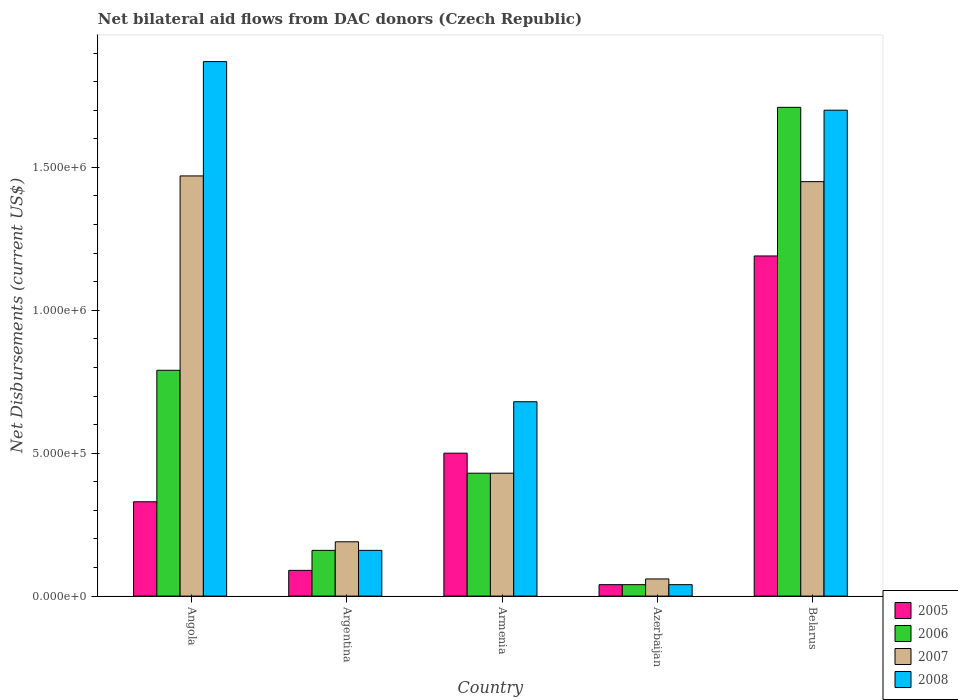How many different coloured bars are there?
Your response must be concise. 4. Are the number of bars per tick equal to the number of legend labels?
Provide a short and direct response. Yes. How many bars are there on the 5th tick from the right?
Your answer should be very brief. 4. What is the label of the 4th group of bars from the left?
Provide a short and direct response. Azerbaijan. What is the net bilateral aid flows in 2008 in Azerbaijan?
Give a very brief answer. 4.00e+04. Across all countries, what is the maximum net bilateral aid flows in 2006?
Give a very brief answer. 1.71e+06. Across all countries, what is the minimum net bilateral aid flows in 2005?
Keep it short and to the point. 4.00e+04. In which country was the net bilateral aid flows in 2005 maximum?
Ensure brevity in your answer.  Belarus. In which country was the net bilateral aid flows in 2005 minimum?
Ensure brevity in your answer.  Azerbaijan. What is the total net bilateral aid flows in 2008 in the graph?
Provide a succinct answer. 4.45e+06. What is the difference between the net bilateral aid flows in 2006 in Armenia and that in Azerbaijan?
Offer a terse response. 3.90e+05. What is the difference between the net bilateral aid flows in 2008 in Angola and the net bilateral aid flows in 2006 in Azerbaijan?
Your answer should be compact. 1.83e+06. What is the average net bilateral aid flows in 2005 per country?
Offer a terse response. 4.30e+05. What is the difference between the net bilateral aid flows of/in 2006 and net bilateral aid flows of/in 2007 in Angola?
Ensure brevity in your answer.  -6.80e+05. What is the ratio of the net bilateral aid flows in 2005 in Angola to that in Azerbaijan?
Provide a succinct answer. 8.25. Is the net bilateral aid flows in 2008 in Armenia less than that in Belarus?
Provide a succinct answer. Yes. What is the difference between the highest and the lowest net bilateral aid flows in 2008?
Your response must be concise. 1.83e+06. In how many countries, is the net bilateral aid flows in 2007 greater than the average net bilateral aid flows in 2007 taken over all countries?
Give a very brief answer. 2. Is it the case that in every country, the sum of the net bilateral aid flows in 2006 and net bilateral aid flows in 2008 is greater than the sum of net bilateral aid flows in 2005 and net bilateral aid flows in 2007?
Provide a short and direct response. No. What does the 2nd bar from the left in Argentina represents?
Keep it short and to the point. 2006. Is it the case that in every country, the sum of the net bilateral aid flows in 2008 and net bilateral aid flows in 2006 is greater than the net bilateral aid flows in 2007?
Make the answer very short. Yes. How many bars are there?
Offer a very short reply. 20. How many countries are there in the graph?
Provide a succinct answer. 5. What is the difference between two consecutive major ticks on the Y-axis?
Offer a terse response. 5.00e+05. Does the graph contain grids?
Offer a terse response. No. How are the legend labels stacked?
Provide a succinct answer. Vertical. What is the title of the graph?
Your answer should be compact. Net bilateral aid flows from DAC donors (Czech Republic). Does "1976" appear as one of the legend labels in the graph?
Your response must be concise. No. What is the label or title of the Y-axis?
Your answer should be compact. Net Disbursements (current US$). What is the Net Disbursements (current US$) in 2006 in Angola?
Offer a very short reply. 7.90e+05. What is the Net Disbursements (current US$) of 2007 in Angola?
Your response must be concise. 1.47e+06. What is the Net Disbursements (current US$) in 2008 in Angola?
Provide a succinct answer. 1.87e+06. What is the Net Disbursements (current US$) of 2005 in Argentina?
Ensure brevity in your answer.  9.00e+04. What is the Net Disbursements (current US$) of 2007 in Argentina?
Your response must be concise. 1.90e+05. What is the Net Disbursements (current US$) in 2006 in Armenia?
Ensure brevity in your answer.  4.30e+05. What is the Net Disbursements (current US$) of 2008 in Armenia?
Your answer should be very brief. 6.80e+05. What is the Net Disbursements (current US$) in 2005 in Azerbaijan?
Make the answer very short. 4.00e+04. What is the Net Disbursements (current US$) of 2006 in Azerbaijan?
Keep it short and to the point. 4.00e+04. What is the Net Disbursements (current US$) of 2005 in Belarus?
Your answer should be very brief. 1.19e+06. What is the Net Disbursements (current US$) in 2006 in Belarus?
Offer a terse response. 1.71e+06. What is the Net Disbursements (current US$) in 2007 in Belarus?
Offer a terse response. 1.45e+06. What is the Net Disbursements (current US$) in 2008 in Belarus?
Your answer should be compact. 1.70e+06. Across all countries, what is the maximum Net Disbursements (current US$) of 2005?
Offer a very short reply. 1.19e+06. Across all countries, what is the maximum Net Disbursements (current US$) in 2006?
Your answer should be compact. 1.71e+06. Across all countries, what is the maximum Net Disbursements (current US$) of 2007?
Offer a very short reply. 1.47e+06. Across all countries, what is the maximum Net Disbursements (current US$) in 2008?
Provide a short and direct response. 1.87e+06. Across all countries, what is the minimum Net Disbursements (current US$) in 2005?
Your response must be concise. 4.00e+04. Across all countries, what is the minimum Net Disbursements (current US$) of 2008?
Your response must be concise. 4.00e+04. What is the total Net Disbursements (current US$) of 2005 in the graph?
Offer a terse response. 2.15e+06. What is the total Net Disbursements (current US$) of 2006 in the graph?
Offer a very short reply. 3.13e+06. What is the total Net Disbursements (current US$) in 2007 in the graph?
Offer a terse response. 3.60e+06. What is the total Net Disbursements (current US$) in 2008 in the graph?
Offer a very short reply. 4.45e+06. What is the difference between the Net Disbursements (current US$) in 2005 in Angola and that in Argentina?
Provide a short and direct response. 2.40e+05. What is the difference between the Net Disbursements (current US$) in 2006 in Angola and that in Argentina?
Provide a short and direct response. 6.30e+05. What is the difference between the Net Disbursements (current US$) in 2007 in Angola and that in Argentina?
Make the answer very short. 1.28e+06. What is the difference between the Net Disbursements (current US$) in 2008 in Angola and that in Argentina?
Keep it short and to the point. 1.71e+06. What is the difference between the Net Disbursements (current US$) in 2005 in Angola and that in Armenia?
Make the answer very short. -1.70e+05. What is the difference between the Net Disbursements (current US$) in 2007 in Angola and that in Armenia?
Offer a very short reply. 1.04e+06. What is the difference between the Net Disbursements (current US$) in 2008 in Angola and that in Armenia?
Ensure brevity in your answer.  1.19e+06. What is the difference between the Net Disbursements (current US$) of 2005 in Angola and that in Azerbaijan?
Ensure brevity in your answer.  2.90e+05. What is the difference between the Net Disbursements (current US$) of 2006 in Angola and that in Azerbaijan?
Make the answer very short. 7.50e+05. What is the difference between the Net Disbursements (current US$) in 2007 in Angola and that in Azerbaijan?
Ensure brevity in your answer.  1.41e+06. What is the difference between the Net Disbursements (current US$) of 2008 in Angola and that in Azerbaijan?
Provide a short and direct response. 1.83e+06. What is the difference between the Net Disbursements (current US$) in 2005 in Angola and that in Belarus?
Keep it short and to the point. -8.60e+05. What is the difference between the Net Disbursements (current US$) of 2006 in Angola and that in Belarus?
Your response must be concise. -9.20e+05. What is the difference between the Net Disbursements (current US$) in 2007 in Angola and that in Belarus?
Give a very brief answer. 2.00e+04. What is the difference between the Net Disbursements (current US$) in 2008 in Angola and that in Belarus?
Provide a short and direct response. 1.70e+05. What is the difference between the Net Disbursements (current US$) of 2005 in Argentina and that in Armenia?
Make the answer very short. -4.10e+05. What is the difference between the Net Disbursements (current US$) of 2006 in Argentina and that in Armenia?
Offer a terse response. -2.70e+05. What is the difference between the Net Disbursements (current US$) in 2007 in Argentina and that in Armenia?
Your response must be concise. -2.40e+05. What is the difference between the Net Disbursements (current US$) in 2008 in Argentina and that in Armenia?
Provide a short and direct response. -5.20e+05. What is the difference between the Net Disbursements (current US$) of 2005 in Argentina and that in Belarus?
Make the answer very short. -1.10e+06. What is the difference between the Net Disbursements (current US$) of 2006 in Argentina and that in Belarus?
Offer a very short reply. -1.55e+06. What is the difference between the Net Disbursements (current US$) in 2007 in Argentina and that in Belarus?
Your response must be concise. -1.26e+06. What is the difference between the Net Disbursements (current US$) of 2008 in Argentina and that in Belarus?
Give a very brief answer. -1.54e+06. What is the difference between the Net Disbursements (current US$) in 2007 in Armenia and that in Azerbaijan?
Your response must be concise. 3.70e+05. What is the difference between the Net Disbursements (current US$) in 2008 in Armenia and that in Azerbaijan?
Offer a very short reply. 6.40e+05. What is the difference between the Net Disbursements (current US$) in 2005 in Armenia and that in Belarus?
Give a very brief answer. -6.90e+05. What is the difference between the Net Disbursements (current US$) in 2006 in Armenia and that in Belarus?
Make the answer very short. -1.28e+06. What is the difference between the Net Disbursements (current US$) of 2007 in Armenia and that in Belarus?
Make the answer very short. -1.02e+06. What is the difference between the Net Disbursements (current US$) in 2008 in Armenia and that in Belarus?
Your answer should be compact. -1.02e+06. What is the difference between the Net Disbursements (current US$) of 2005 in Azerbaijan and that in Belarus?
Provide a succinct answer. -1.15e+06. What is the difference between the Net Disbursements (current US$) in 2006 in Azerbaijan and that in Belarus?
Give a very brief answer. -1.67e+06. What is the difference between the Net Disbursements (current US$) in 2007 in Azerbaijan and that in Belarus?
Make the answer very short. -1.39e+06. What is the difference between the Net Disbursements (current US$) of 2008 in Azerbaijan and that in Belarus?
Offer a very short reply. -1.66e+06. What is the difference between the Net Disbursements (current US$) in 2005 in Angola and the Net Disbursements (current US$) in 2007 in Argentina?
Provide a short and direct response. 1.40e+05. What is the difference between the Net Disbursements (current US$) of 2005 in Angola and the Net Disbursements (current US$) of 2008 in Argentina?
Provide a short and direct response. 1.70e+05. What is the difference between the Net Disbursements (current US$) of 2006 in Angola and the Net Disbursements (current US$) of 2007 in Argentina?
Your answer should be compact. 6.00e+05. What is the difference between the Net Disbursements (current US$) of 2006 in Angola and the Net Disbursements (current US$) of 2008 in Argentina?
Provide a succinct answer. 6.30e+05. What is the difference between the Net Disbursements (current US$) in 2007 in Angola and the Net Disbursements (current US$) in 2008 in Argentina?
Keep it short and to the point. 1.31e+06. What is the difference between the Net Disbursements (current US$) in 2005 in Angola and the Net Disbursements (current US$) in 2006 in Armenia?
Your answer should be very brief. -1.00e+05. What is the difference between the Net Disbursements (current US$) in 2005 in Angola and the Net Disbursements (current US$) in 2007 in Armenia?
Keep it short and to the point. -1.00e+05. What is the difference between the Net Disbursements (current US$) of 2005 in Angola and the Net Disbursements (current US$) of 2008 in Armenia?
Your answer should be very brief. -3.50e+05. What is the difference between the Net Disbursements (current US$) in 2006 in Angola and the Net Disbursements (current US$) in 2007 in Armenia?
Your response must be concise. 3.60e+05. What is the difference between the Net Disbursements (current US$) in 2006 in Angola and the Net Disbursements (current US$) in 2008 in Armenia?
Ensure brevity in your answer.  1.10e+05. What is the difference between the Net Disbursements (current US$) of 2007 in Angola and the Net Disbursements (current US$) of 2008 in Armenia?
Provide a short and direct response. 7.90e+05. What is the difference between the Net Disbursements (current US$) in 2006 in Angola and the Net Disbursements (current US$) in 2007 in Azerbaijan?
Provide a short and direct response. 7.30e+05. What is the difference between the Net Disbursements (current US$) of 2006 in Angola and the Net Disbursements (current US$) of 2008 in Azerbaijan?
Offer a very short reply. 7.50e+05. What is the difference between the Net Disbursements (current US$) in 2007 in Angola and the Net Disbursements (current US$) in 2008 in Azerbaijan?
Give a very brief answer. 1.43e+06. What is the difference between the Net Disbursements (current US$) of 2005 in Angola and the Net Disbursements (current US$) of 2006 in Belarus?
Offer a terse response. -1.38e+06. What is the difference between the Net Disbursements (current US$) of 2005 in Angola and the Net Disbursements (current US$) of 2007 in Belarus?
Provide a short and direct response. -1.12e+06. What is the difference between the Net Disbursements (current US$) in 2005 in Angola and the Net Disbursements (current US$) in 2008 in Belarus?
Provide a succinct answer. -1.37e+06. What is the difference between the Net Disbursements (current US$) of 2006 in Angola and the Net Disbursements (current US$) of 2007 in Belarus?
Your response must be concise. -6.60e+05. What is the difference between the Net Disbursements (current US$) of 2006 in Angola and the Net Disbursements (current US$) of 2008 in Belarus?
Make the answer very short. -9.10e+05. What is the difference between the Net Disbursements (current US$) of 2005 in Argentina and the Net Disbursements (current US$) of 2006 in Armenia?
Ensure brevity in your answer.  -3.40e+05. What is the difference between the Net Disbursements (current US$) in 2005 in Argentina and the Net Disbursements (current US$) in 2008 in Armenia?
Keep it short and to the point. -5.90e+05. What is the difference between the Net Disbursements (current US$) in 2006 in Argentina and the Net Disbursements (current US$) in 2007 in Armenia?
Your answer should be compact. -2.70e+05. What is the difference between the Net Disbursements (current US$) of 2006 in Argentina and the Net Disbursements (current US$) of 2008 in Armenia?
Offer a very short reply. -5.20e+05. What is the difference between the Net Disbursements (current US$) in 2007 in Argentina and the Net Disbursements (current US$) in 2008 in Armenia?
Your answer should be very brief. -4.90e+05. What is the difference between the Net Disbursements (current US$) of 2005 in Argentina and the Net Disbursements (current US$) of 2007 in Azerbaijan?
Make the answer very short. 3.00e+04. What is the difference between the Net Disbursements (current US$) of 2006 in Argentina and the Net Disbursements (current US$) of 2008 in Azerbaijan?
Give a very brief answer. 1.20e+05. What is the difference between the Net Disbursements (current US$) in 2007 in Argentina and the Net Disbursements (current US$) in 2008 in Azerbaijan?
Your answer should be compact. 1.50e+05. What is the difference between the Net Disbursements (current US$) of 2005 in Argentina and the Net Disbursements (current US$) of 2006 in Belarus?
Make the answer very short. -1.62e+06. What is the difference between the Net Disbursements (current US$) of 2005 in Argentina and the Net Disbursements (current US$) of 2007 in Belarus?
Make the answer very short. -1.36e+06. What is the difference between the Net Disbursements (current US$) in 2005 in Argentina and the Net Disbursements (current US$) in 2008 in Belarus?
Make the answer very short. -1.61e+06. What is the difference between the Net Disbursements (current US$) in 2006 in Argentina and the Net Disbursements (current US$) in 2007 in Belarus?
Your answer should be very brief. -1.29e+06. What is the difference between the Net Disbursements (current US$) in 2006 in Argentina and the Net Disbursements (current US$) in 2008 in Belarus?
Your answer should be very brief. -1.54e+06. What is the difference between the Net Disbursements (current US$) in 2007 in Argentina and the Net Disbursements (current US$) in 2008 in Belarus?
Make the answer very short. -1.51e+06. What is the difference between the Net Disbursements (current US$) of 2006 in Armenia and the Net Disbursements (current US$) of 2007 in Azerbaijan?
Your response must be concise. 3.70e+05. What is the difference between the Net Disbursements (current US$) of 2007 in Armenia and the Net Disbursements (current US$) of 2008 in Azerbaijan?
Provide a short and direct response. 3.90e+05. What is the difference between the Net Disbursements (current US$) of 2005 in Armenia and the Net Disbursements (current US$) of 2006 in Belarus?
Offer a terse response. -1.21e+06. What is the difference between the Net Disbursements (current US$) in 2005 in Armenia and the Net Disbursements (current US$) in 2007 in Belarus?
Provide a succinct answer. -9.50e+05. What is the difference between the Net Disbursements (current US$) in 2005 in Armenia and the Net Disbursements (current US$) in 2008 in Belarus?
Your response must be concise. -1.20e+06. What is the difference between the Net Disbursements (current US$) in 2006 in Armenia and the Net Disbursements (current US$) in 2007 in Belarus?
Your answer should be compact. -1.02e+06. What is the difference between the Net Disbursements (current US$) of 2006 in Armenia and the Net Disbursements (current US$) of 2008 in Belarus?
Provide a short and direct response. -1.27e+06. What is the difference between the Net Disbursements (current US$) in 2007 in Armenia and the Net Disbursements (current US$) in 2008 in Belarus?
Give a very brief answer. -1.27e+06. What is the difference between the Net Disbursements (current US$) of 2005 in Azerbaijan and the Net Disbursements (current US$) of 2006 in Belarus?
Your answer should be very brief. -1.67e+06. What is the difference between the Net Disbursements (current US$) in 2005 in Azerbaijan and the Net Disbursements (current US$) in 2007 in Belarus?
Give a very brief answer. -1.41e+06. What is the difference between the Net Disbursements (current US$) in 2005 in Azerbaijan and the Net Disbursements (current US$) in 2008 in Belarus?
Your response must be concise. -1.66e+06. What is the difference between the Net Disbursements (current US$) in 2006 in Azerbaijan and the Net Disbursements (current US$) in 2007 in Belarus?
Make the answer very short. -1.41e+06. What is the difference between the Net Disbursements (current US$) of 2006 in Azerbaijan and the Net Disbursements (current US$) of 2008 in Belarus?
Offer a terse response. -1.66e+06. What is the difference between the Net Disbursements (current US$) of 2007 in Azerbaijan and the Net Disbursements (current US$) of 2008 in Belarus?
Give a very brief answer. -1.64e+06. What is the average Net Disbursements (current US$) in 2006 per country?
Keep it short and to the point. 6.26e+05. What is the average Net Disbursements (current US$) of 2007 per country?
Give a very brief answer. 7.20e+05. What is the average Net Disbursements (current US$) in 2008 per country?
Give a very brief answer. 8.90e+05. What is the difference between the Net Disbursements (current US$) in 2005 and Net Disbursements (current US$) in 2006 in Angola?
Offer a very short reply. -4.60e+05. What is the difference between the Net Disbursements (current US$) of 2005 and Net Disbursements (current US$) of 2007 in Angola?
Offer a terse response. -1.14e+06. What is the difference between the Net Disbursements (current US$) in 2005 and Net Disbursements (current US$) in 2008 in Angola?
Make the answer very short. -1.54e+06. What is the difference between the Net Disbursements (current US$) of 2006 and Net Disbursements (current US$) of 2007 in Angola?
Offer a terse response. -6.80e+05. What is the difference between the Net Disbursements (current US$) in 2006 and Net Disbursements (current US$) in 2008 in Angola?
Your response must be concise. -1.08e+06. What is the difference between the Net Disbursements (current US$) in 2007 and Net Disbursements (current US$) in 2008 in Angola?
Provide a succinct answer. -4.00e+05. What is the difference between the Net Disbursements (current US$) in 2005 and Net Disbursements (current US$) in 2007 in Argentina?
Your response must be concise. -1.00e+05. What is the difference between the Net Disbursements (current US$) in 2006 and Net Disbursements (current US$) in 2007 in Argentina?
Ensure brevity in your answer.  -3.00e+04. What is the difference between the Net Disbursements (current US$) in 2006 and Net Disbursements (current US$) in 2008 in Argentina?
Make the answer very short. 0. What is the difference between the Net Disbursements (current US$) of 2007 and Net Disbursements (current US$) of 2008 in Argentina?
Make the answer very short. 3.00e+04. What is the difference between the Net Disbursements (current US$) of 2005 and Net Disbursements (current US$) of 2006 in Armenia?
Provide a short and direct response. 7.00e+04. What is the difference between the Net Disbursements (current US$) of 2005 and Net Disbursements (current US$) of 2008 in Armenia?
Provide a succinct answer. -1.80e+05. What is the difference between the Net Disbursements (current US$) of 2006 and Net Disbursements (current US$) of 2007 in Armenia?
Offer a terse response. 0. What is the difference between the Net Disbursements (current US$) of 2007 and Net Disbursements (current US$) of 2008 in Armenia?
Ensure brevity in your answer.  -2.50e+05. What is the difference between the Net Disbursements (current US$) in 2005 and Net Disbursements (current US$) in 2007 in Azerbaijan?
Make the answer very short. -2.00e+04. What is the difference between the Net Disbursements (current US$) of 2006 and Net Disbursements (current US$) of 2007 in Azerbaijan?
Your answer should be compact. -2.00e+04. What is the difference between the Net Disbursements (current US$) of 2006 and Net Disbursements (current US$) of 2008 in Azerbaijan?
Keep it short and to the point. 0. What is the difference between the Net Disbursements (current US$) of 2007 and Net Disbursements (current US$) of 2008 in Azerbaijan?
Offer a terse response. 2.00e+04. What is the difference between the Net Disbursements (current US$) of 2005 and Net Disbursements (current US$) of 2006 in Belarus?
Offer a very short reply. -5.20e+05. What is the difference between the Net Disbursements (current US$) in 2005 and Net Disbursements (current US$) in 2007 in Belarus?
Your answer should be very brief. -2.60e+05. What is the difference between the Net Disbursements (current US$) of 2005 and Net Disbursements (current US$) of 2008 in Belarus?
Make the answer very short. -5.10e+05. What is the difference between the Net Disbursements (current US$) in 2006 and Net Disbursements (current US$) in 2008 in Belarus?
Your answer should be very brief. 10000. What is the ratio of the Net Disbursements (current US$) in 2005 in Angola to that in Argentina?
Give a very brief answer. 3.67. What is the ratio of the Net Disbursements (current US$) in 2006 in Angola to that in Argentina?
Your answer should be very brief. 4.94. What is the ratio of the Net Disbursements (current US$) in 2007 in Angola to that in Argentina?
Offer a terse response. 7.74. What is the ratio of the Net Disbursements (current US$) in 2008 in Angola to that in Argentina?
Your response must be concise. 11.69. What is the ratio of the Net Disbursements (current US$) of 2005 in Angola to that in Armenia?
Keep it short and to the point. 0.66. What is the ratio of the Net Disbursements (current US$) in 2006 in Angola to that in Armenia?
Provide a short and direct response. 1.84. What is the ratio of the Net Disbursements (current US$) of 2007 in Angola to that in Armenia?
Your response must be concise. 3.42. What is the ratio of the Net Disbursements (current US$) in 2008 in Angola to that in Armenia?
Offer a very short reply. 2.75. What is the ratio of the Net Disbursements (current US$) in 2005 in Angola to that in Azerbaijan?
Give a very brief answer. 8.25. What is the ratio of the Net Disbursements (current US$) in 2006 in Angola to that in Azerbaijan?
Your response must be concise. 19.75. What is the ratio of the Net Disbursements (current US$) in 2007 in Angola to that in Azerbaijan?
Make the answer very short. 24.5. What is the ratio of the Net Disbursements (current US$) of 2008 in Angola to that in Azerbaijan?
Offer a very short reply. 46.75. What is the ratio of the Net Disbursements (current US$) of 2005 in Angola to that in Belarus?
Keep it short and to the point. 0.28. What is the ratio of the Net Disbursements (current US$) in 2006 in Angola to that in Belarus?
Offer a terse response. 0.46. What is the ratio of the Net Disbursements (current US$) in 2007 in Angola to that in Belarus?
Your answer should be very brief. 1.01. What is the ratio of the Net Disbursements (current US$) in 2008 in Angola to that in Belarus?
Your answer should be compact. 1.1. What is the ratio of the Net Disbursements (current US$) of 2005 in Argentina to that in Armenia?
Make the answer very short. 0.18. What is the ratio of the Net Disbursements (current US$) of 2006 in Argentina to that in Armenia?
Offer a very short reply. 0.37. What is the ratio of the Net Disbursements (current US$) in 2007 in Argentina to that in Armenia?
Your answer should be compact. 0.44. What is the ratio of the Net Disbursements (current US$) of 2008 in Argentina to that in Armenia?
Your answer should be compact. 0.24. What is the ratio of the Net Disbursements (current US$) of 2005 in Argentina to that in Azerbaijan?
Provide a succinct answer. 2.25. What is the ratio of the Net Disbursements (current US$) of 2006 in Argentina to that in Azerbaijan?
Offer a very short reply. 4. What is the ratio of the Net Disbursements (current US$) in 2007 in Argentina to that in Azerbaijan?
Your response must be concise. 3.17. What is the ratio of the Net Disbursements (current US$) of 2005 in Argentina to that in Belarus?
Make the answer very short. 0.08. What is the ratio of the Net Disbursements (current US$) in 2006 in Argentina to that in Belarus?
Make the answer very short. 0.09. What is the ratio of the Net Disbursements (current US$) of 2007 in Argentina to that in Belarus?
Your response must be concise. 0.13. What is the ratio of the Net Disbursements (current US$) of 2008 in Argentina to that in Belarus?
Ensure brevity in your answer.  0.09. What is the ratio of the Net Disbursements (current US$) of 2005 in Armenia to that in Azerbaijan?
Your answer should be very brief. 12.5. What is the ratio of the Net Disbursements (current US$) of 2006 in Armenia to that in Azerbaijan?
Provide a succinct answer. 10.75. What is the ratio of the Net Disbursements (current US$) of 2007 in Armenia to that in Azerbaijan?
Provide a succinct answer. 7.17. What is the ratio of the Net Disbursements (current US$) of 2008 in Armenia to that in Azerbaijan?
Your answer should be very brief. 17. What is the ratio of the Net Disbursements (current US$) of 2005 in Armenia to that in Belarus?
Offer a very short reply. 0.42. What is the ratio of the Net Disbursements (current US$) of 2006 in Armenia to that in Belarus?
Your answer should be very brief. 0.25. What is the ratio of the Net Disbursements (current US$) in 2007 in Armenia to that in Belarus?
Your response must be concise. 0.3. What is the ratio of the Net Disbursements (current US$) in 2005 in Azerbaijan to that in Belarus?
Your answer should be compact. 0.03. What is the ratio of the Net Disbursements (current US$) in 2006 in Azerbaijan to that in Belarus?
Make the answer very short. 0.02. What is the ratio of the Net Disbursements (current US$) of 2007 in Azerbaijan to that in Belarus?
Provide a succinct answer. 0.04. What is the ratio of the Net Disbursements (current US$) of 2008 in Azerbaijan to that in Belarus?
Provide a short and direct response. 0.02. What is the difference between the highest and the second highest Net Disbursements (current US$) of 2005?
Keep it short and to the point. 6.90e+05. What is the difference between the highest and the second highest Net Disbursements (current US$) in 2006?
Offer a very short reply. 9.20e+05. What is the difference between the highest and the lowest Net Disbursements (current US$) in 2005?
Your response must be concise. 1.15e+06. What is the difference between the highest and the lowest Net Disbursements (current US$) of 2006?
Make the answer very short. 1.67e+06. What is the difference between the highest and the lowest Net Disbursements (current US$) in 2007?
Your answer should be compact. 1.41e+06. What is the difference between the highest and the lowest Net Disbursements (current US$) of 2008?
Offer a very short reply. 1.83e+06. 